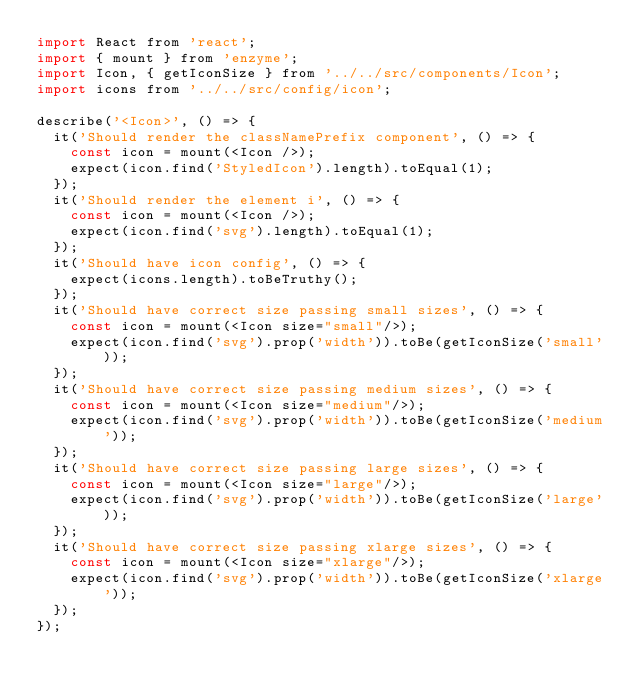Convert code to text. <code><loc_0><loc_0><loc_500><loc_500><_JavaScript_>import React from 'react';
import { mount } from 'enzyme';
import Icon, { getIconSize } from '../../src/components/Icon';
import icons from '../../src/config/icon';

describe('<Icon>', () => {
  it('Should render the classNamePrefix component', () => {
    const icon = mount(<Icon />);
    expect(icon.find('StyledIcon').length).toEqual(1);
  });
  it('Should render the element i', () => {
    const icon = mount(<Icon />);
    expect(icon.find('svg').length).toEqual(1);
  });
  it('Should have icon config', () => {
    expect(icons.length).toBeTruthy();
  });
  it('Should have correct size passing small sizes', () => {
    const icon = mount(<Icon size="small"/>);
    expect(icon.find('svg').prop('width')).toBe(getIconSize('small'));
  });
  it('Should have correct size passing medium sizes', () => {
    const icon = mount(<Icon size="medium"/>);
    expect(icon.find('svg').prop('width')).toBe(getIconSize('medium'));
  });
  it('Should have correct size passing large sizes', () => {
    const icon = mount(<Icon size="large"/>);
    expect(icon.find('svg').prop('width')).toBe(getIconSize('large'));
  });
  it('Should have correct size passing xlarge sizes', () => {
    const icon = mount(<Icon size="xlarge"/>);
    expect(icon.find('svg').prop('width')).toBe(getIconSize('xlarge'));
  });
});
</code> 